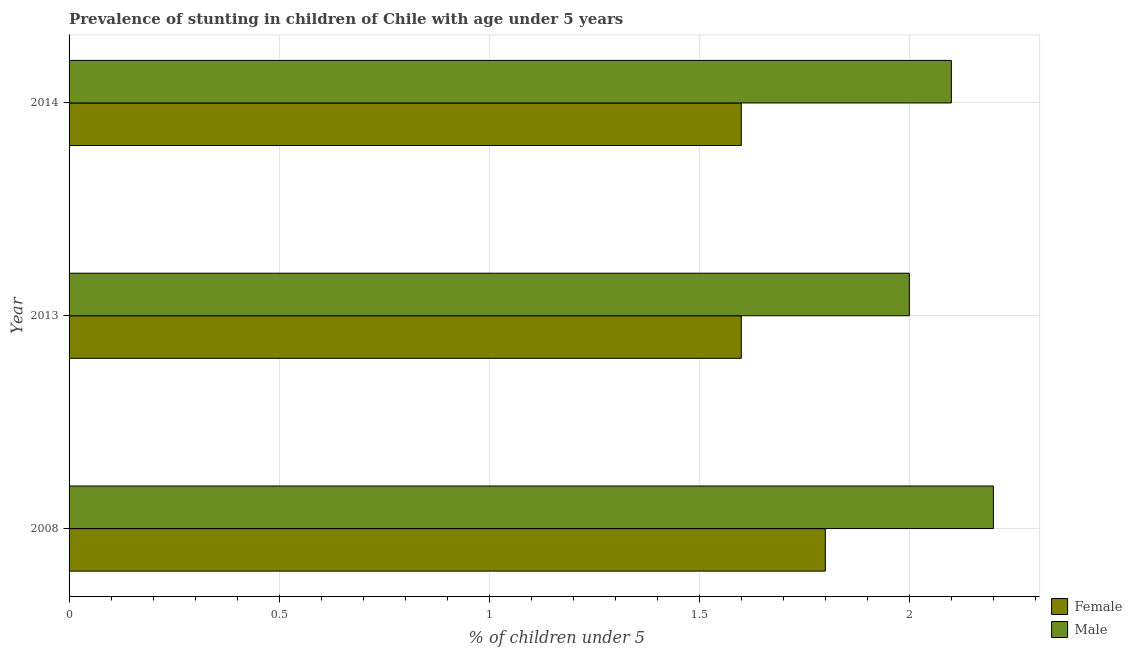How many different coloured bars are there?
Make the answer very short. 2. Are the number of bars per tick equal to the number of legend labels?
Your answer should be compact. Yes. How many bars are there on the 3rd tick from the top?
Ensure brevity in your answer.  2. In how many cases, is the number of bars for a given year not equal to the number of legend labels?
Give a very brief answer. 0. What is the percentage of stunted female children in 2013?
Offer a terse response. 1.6. Across all years, what is the maximum percentage of stunted male children?
Keep it short and to the point. 2.2. In which year was the percentage of stunted male children maximum?
Your answer should be compact. 2008. What is the total percentage of stunted male children in the graph?
Your answer should be compact. 6.3. What is the difference between the percentage of stunted female children in 2008 and that in 2013?
Offer a terse response. 0.2. What is the difference between the percentage of stunted male children in 2008 and the percentage of stunted female children in 2014?
Provide a short and direct response. 0.6. What is the average percentage of stunted female children per year?
Provide a succinct answer. 1.67. In the year 2014, what is the difference between the percentage of stunted male children and percentage of stunted female children?
Your response must be concise. 0.5. Is the difference between the percentage of stunted female children in 2008 and 2014 greater than the difference between the percentage of stunted male children in 2008 and 2014?
Your response must be concise. Yes. What is the difference between the highest and the second highest percentage of stunted female children?
Keep it short and to the point. 0.2. Is the sum of the percentage of stunted male children in 2008 and 2013 greater than the maximum percentage of stunted female children across all years?
Your answer should be compact. Yes. How many bars are there?
Provide a succinct answer. 6. Are all the bars in the graph horizontal?
Your answer should be compact. Yes. How many years are there in the graph?
Your answer should be compact. 3. What is the difference between two consecutive major ticks on the X-axis?
Your answer should be compact. 0.5. Does the graph contain any zero values?
Keep it short and to the point. No. Where does the legend appear in the graph?
Offer a very short reply. Bottom right. How many legend labels are there?
Offer a terse response. 2. What is the title of the graph?
Ensure brevity in your answer.  Prevalence of stunting in children of Chile with age under 5 years. What is the label or title of the X-axis?
Give a very brief answer.  % of children under 5. What is the  % of children under 5 in Female in 2008?
Offer a terse response. 1.8. What is the  % of children under 5 in Male in 2008?
Your answer should be very brief. 2.2. What is the  % of children under 5 of Female in 2013?
Ensure brevity in your answer.  1.6. What is the  % of children under 5 in Female in 2014?
Provide a short and direct response. 1.6. What is the  % of children under 5 in Male in 2014?
Ensure brevity in your answer.  2.1. Across all years, what is the maximum  % of children under 5 in Female?
Provide a succinct answer. 1.8. Across all years, what is the maximum  % of children under 5 in Male?
Give a very brief answer. 2.2. Across all years, what is the minimum  % of children under 5 of Female?
Make the answer very short. 1.6. What is the total  % of children under 5 of Male in the graph?
Offer a very short reply. 6.3. What is the difference between the  % of children under 5 in Female in 2008 and that in 2014?
Ensure brevity in your answer.  0.2. What is the difference between the  % of children under 5 of Male in 2013 and that in 2014?
Give a very brief answer. -0.1. What is the average  % of children under 5 in Male per year?
Offer a very short reply. 2.1. In the year 2008, what is the difference between the  % of children under 5 in Female and  % of children under 5 in Male?
Provide a succinct answer. -0.4. In the year 2013, what is the difference between the  % of children under 5 of Female and  % of children under 5 of Male?
Give a very brief answer. -0.4. In the year 2014, what is the difference between the  % of children under 5 of Female and  % of children under 5 of Male?
Offer a very short reply. -0.5. What is the ratio of the  % of children under 5 of Female in 2008 to that in 2013?
Offer a very short reply. 1.12. What is the ratio of the  % of children under 5 of Male in 2008 to that in 2013?
Your response must be concise. 1.1. What is the ratio of the  % of children under 5 of Male in 2008 to that in 2014?
Provide a short and direct response. 1.05. What is the ratio of the  % of children under 5 in Female in 2013 to that in 2014?
Keep it short and to the point. 1. What is the difference between the highest and the second highest  % of children under 5 of Female?
Make the answer very short. 0.2. What is the difference between the highest and the lowest  % of children under 5 in Male?
Give a very brief answer. 0.2. 